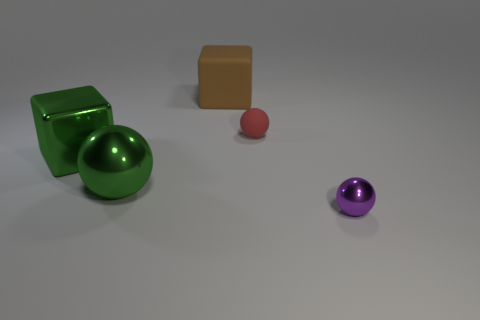Subtract all green metal balls. How many balls are left? 2 Add 1 big rubber spheres. How many objects exist? 6 Subtract all blocks. How many objects are left? 3 Subtract all gray spheres. Subtract all purple cylinders. How many spheres are left? 3 Add 4 large metallic cubes. How many large metallic cubes exist? 5 Subtract 0 yellow cylinders. How many objects are left? 5 Subtract all big shiny things. Subtract all small rubber spheres. How many objects are left? 2 Add 5 large green shiny balls. How many large green shiny balls are left? 6 